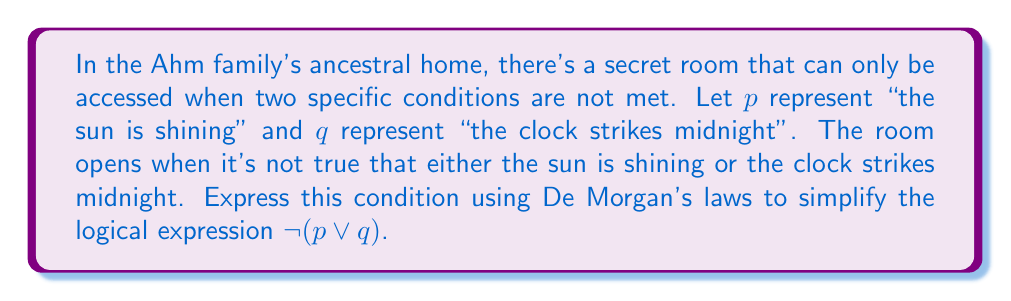Could you help me with this problem? To simplify this logical expression using De Morgan's laws, we'll follow these steps:

1) The original expression is $\neg(p \vee q)$, where $\neg$ represents negation, $\vee$ represents logical OR.

2) De Morgan's law states that the negation of a disjunction is the conjunction of the negations. In symbols:

   $\neg(A \vee B) \equiv (\neg A) \wedge (\neg B)$

3) Applying this to our expression:

   $\neg(p \vee q) \equiv (\neg p) \wedge (\neg q)$

4) This can be interpreted as: "It's not true that the sun is shining AND it's not true that the clock strikes midnight"

5) In other words, for the Ahm family's secret room to open, it must be both not sunny and not midnight.
Answer: $(\neg p) \wedge (\neg q)$ 